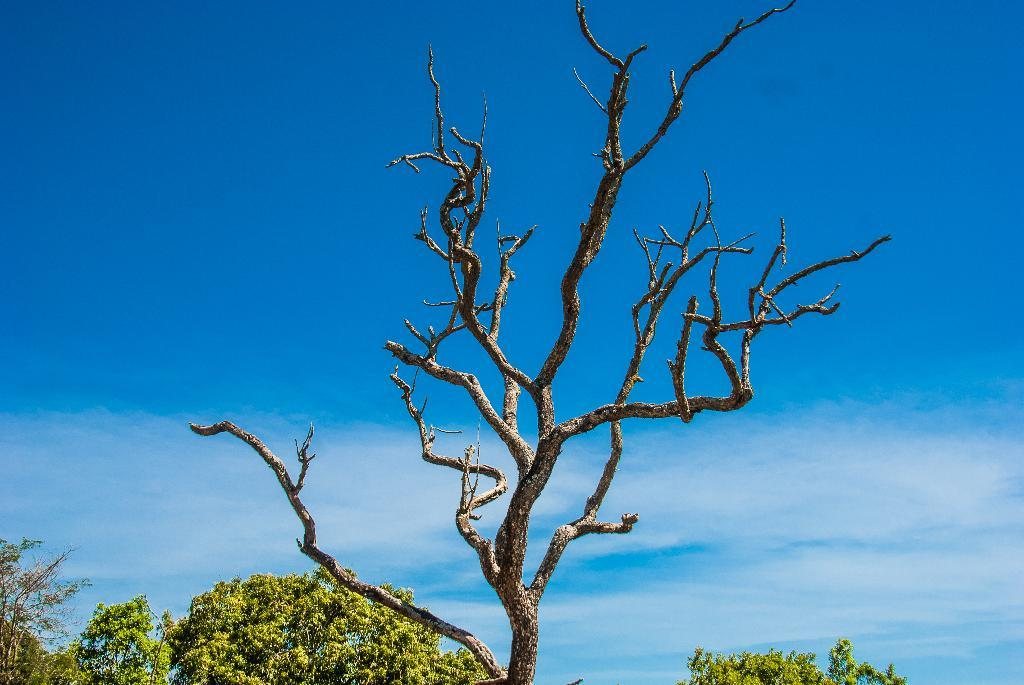What type of vegetation is visible in the front of the image? There are trees in the front of the image. What part of the natural environment can be seen in the background of the image? The sky is visible in the background of the image. How many potatoes are visible in the image? There are no potatoes present in the image. What type of haircut can be seen on the trees in the image? Trees do not have haircuts, as they are plants and not people. 